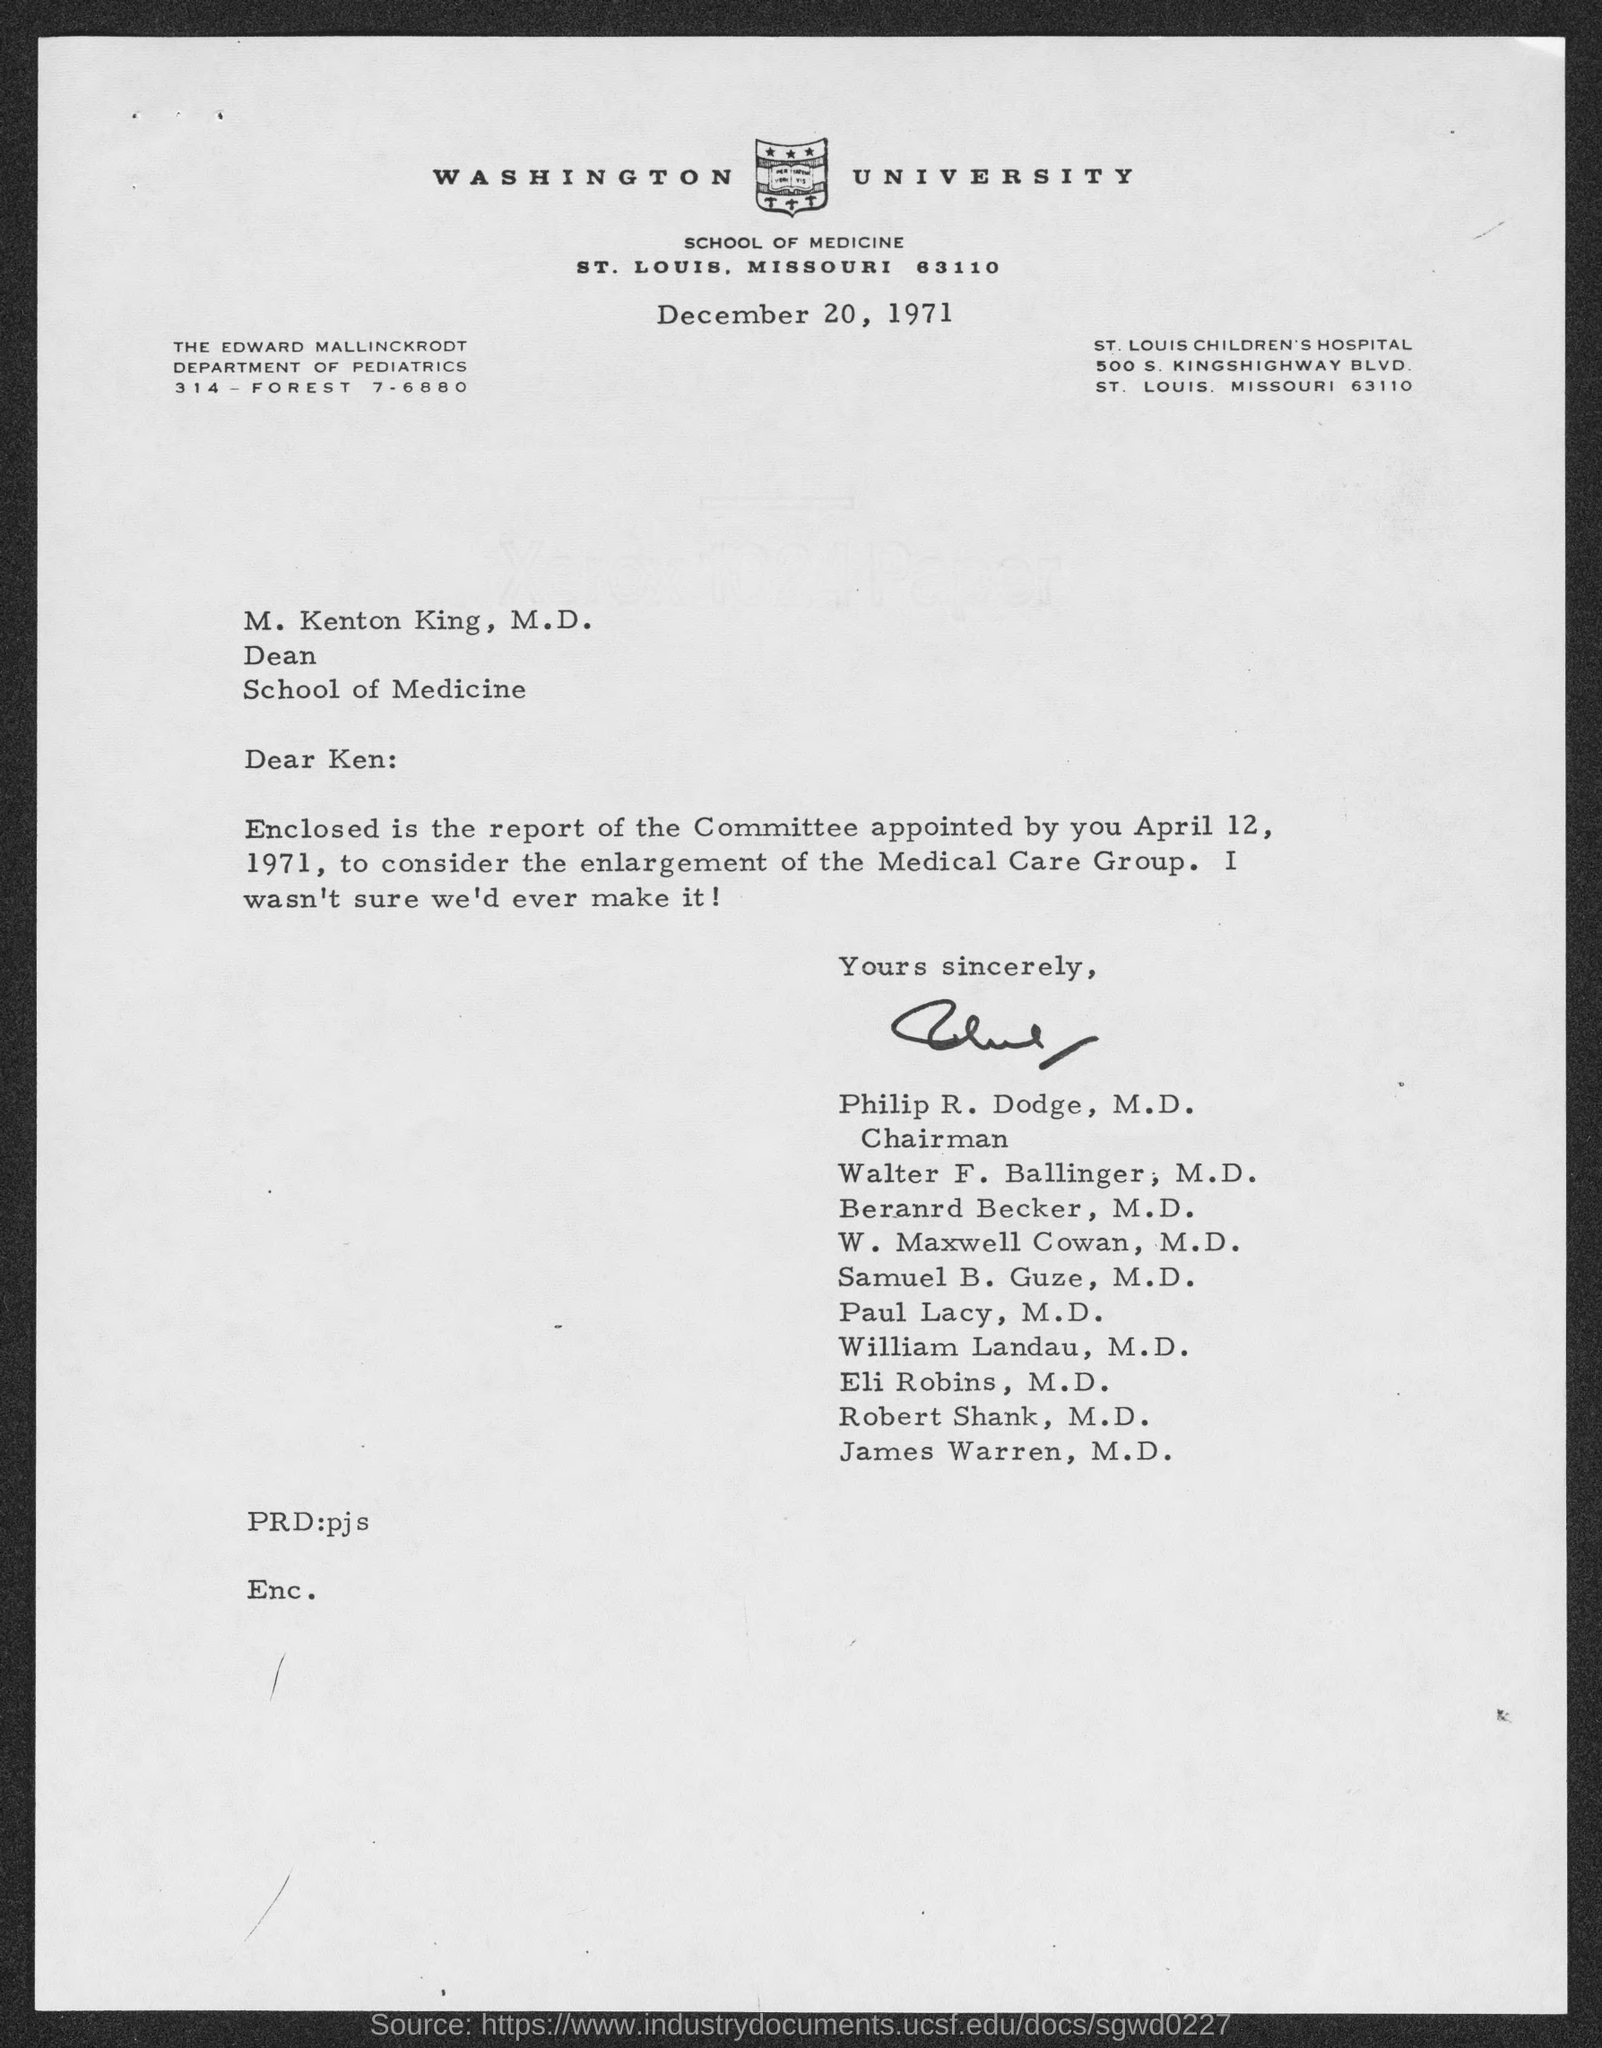Point out several critical features in this image. The letter is dated December 20, 1971. 